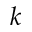Convert formula to latex. <formula><loc_0><loc_0><loc_500><loc_500>k</formula> 